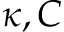<formula> <loc_0><loc_0><loc_500><loc_500>\kappa , C</formula> 